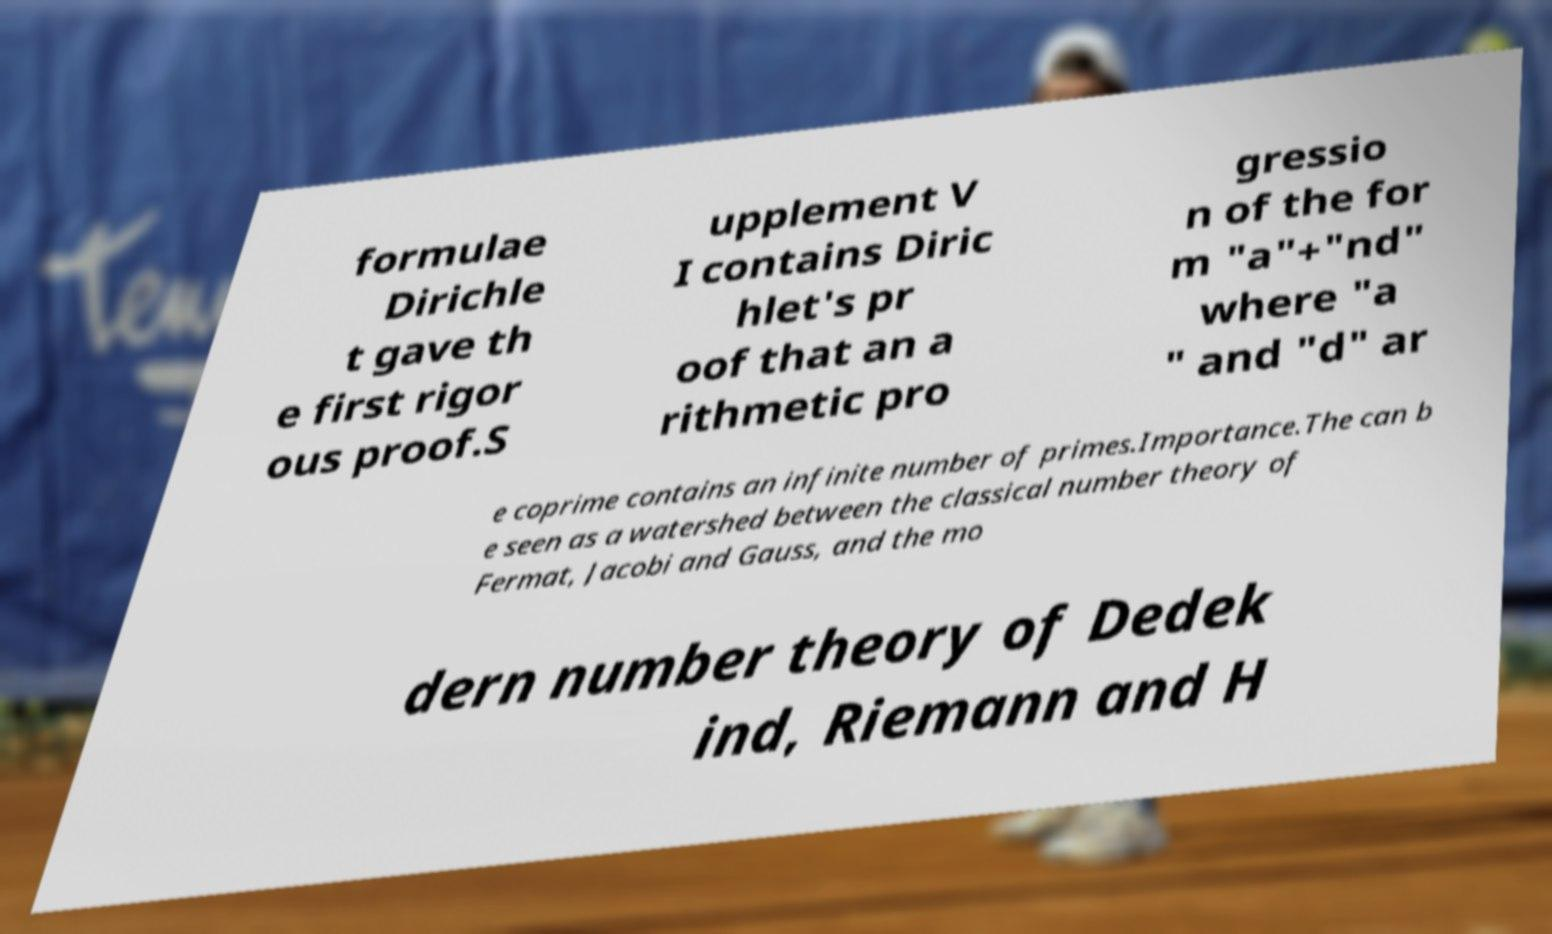Could you assist in decoding the text presented in this image and type it out clearly? formulae Dirichle t gave th e first rigor ous proof.S upplement V I contains Diric hlet's pr oof that an a rithmetic pro gressio n of the for m "a"+"nd" where "a " and "d" ar e coprime contains an infinite number of primes.Importance.The can b e seen as a watershed between the classical number theory of Fermat, Jacobi and Gauss, and the mo dern number theory of Dedek ind, Riemann and H 